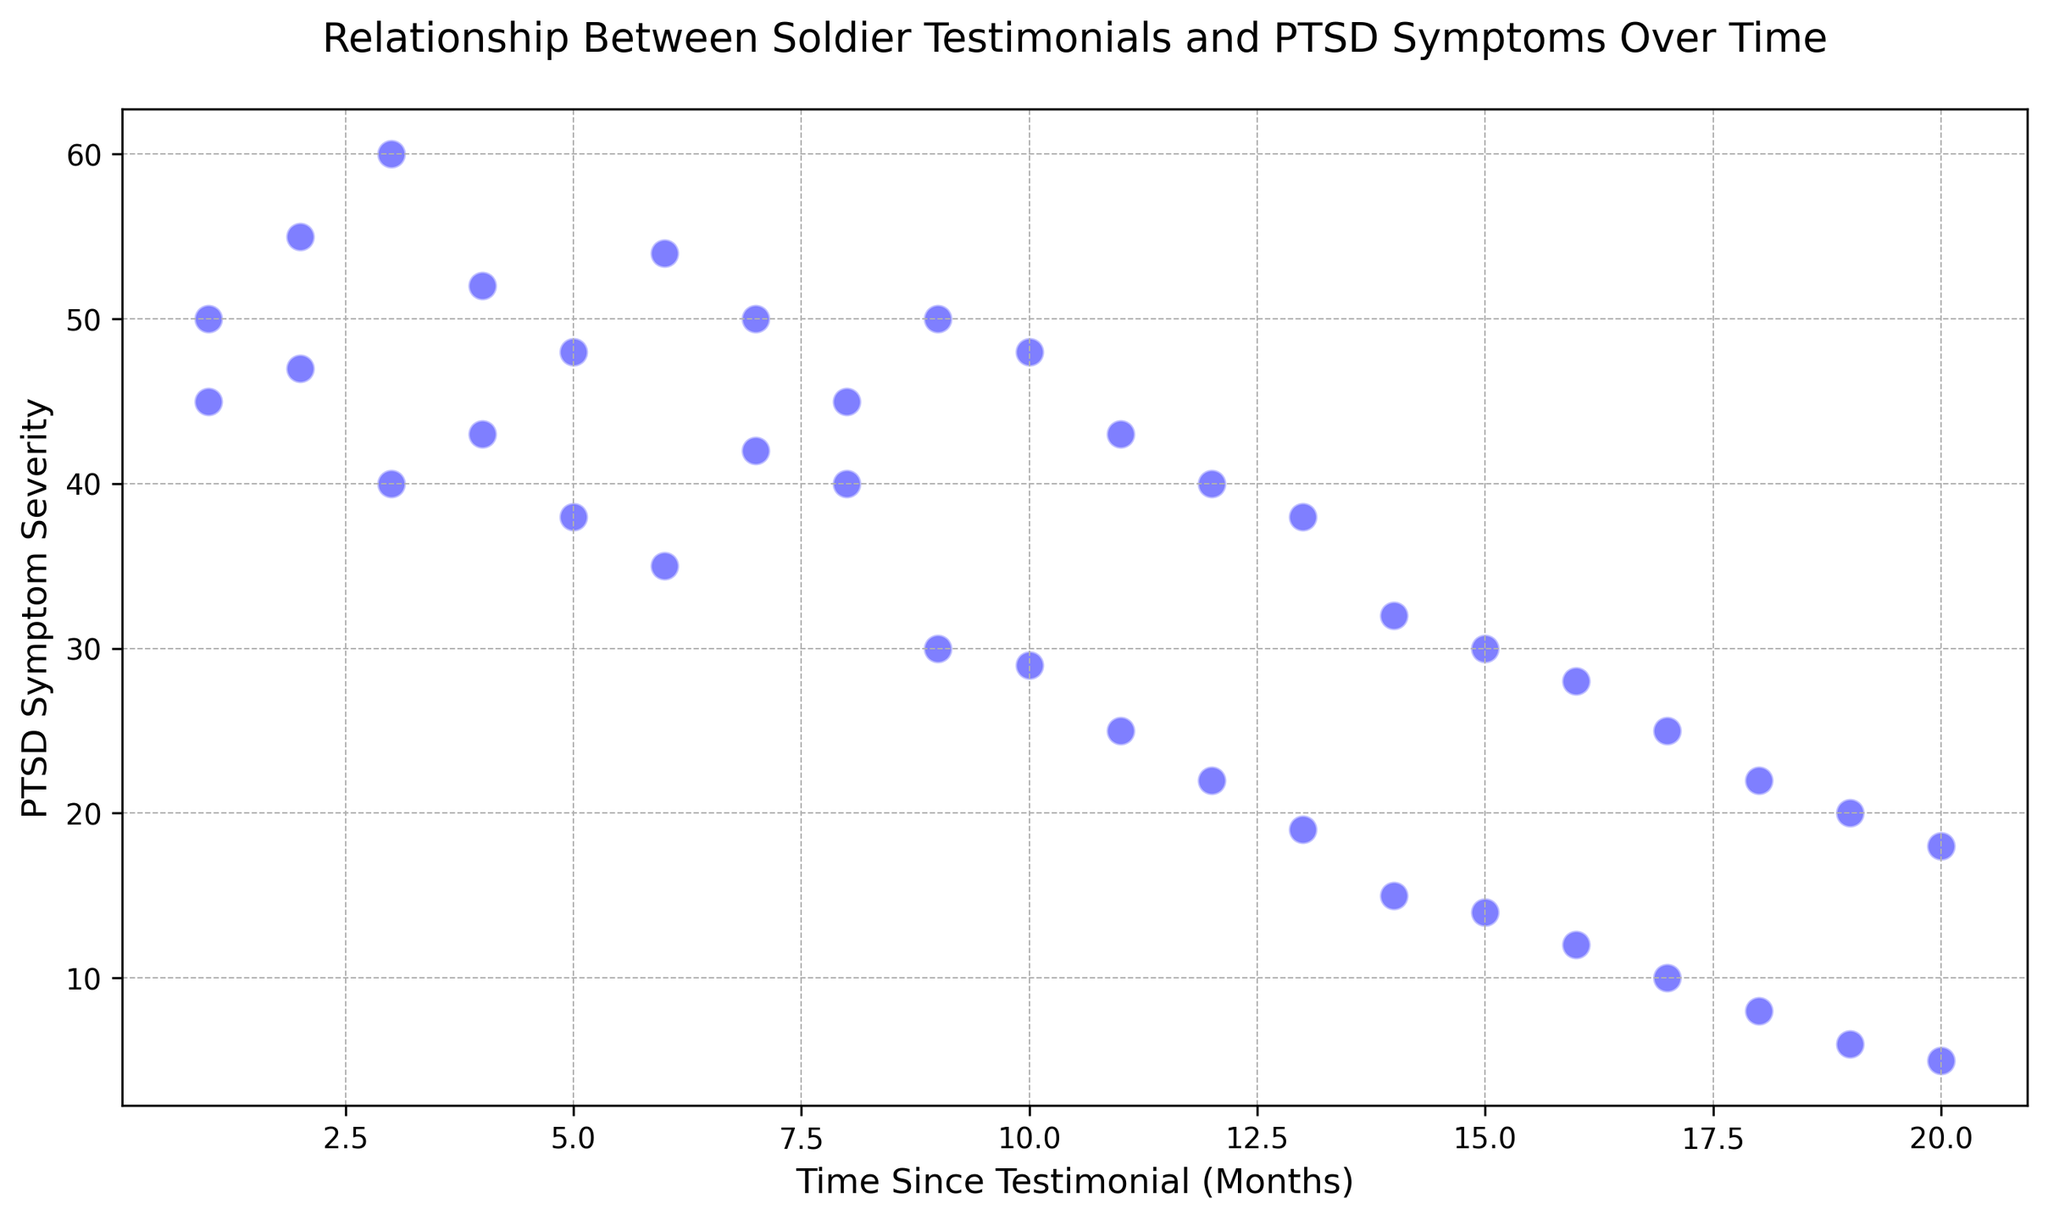What is the trend of PTSD symptom severity over time? To identify the trend, observe how the PTSD symptom severity values change as the time since testimonial increases along the x-axis. In general, the points tend to decrease as time progresses, indicating that PTSD symptoms become less severe over time.
Answer: Decreasing trend Which month shows the highest PTSD symptom severity? Look at the y-axis to find the highest point. The highest PTSD symptom severity is 60, which occurs at month 3.
Answer: Month 3 Is there any month where PTSD symptom severity is below 10? Examine the y-axis and look for points below the 10 mark. The lowest PTSD symptom severity values are 8, 6, and 5, which occur at months 18, 19, and 20 respectively.
Answer: Yes, months 18, 19, and 20 How do the PTSD symptom severities at months 6 and 7 compare with each other? At month 6, the values are 35 and 54. At month 7, the values are 42 and 50. Comparing these, month 6 has one value higher and one lower than month 7.
Answer: Mixed comparison, one higher and one lower What is the combined PTSD symptom severity of testimonials given at month 10? Sum the PTSD symptom severity values at month 10. These are 29 and 48. So, the combined severity is 29 + 48 = 77.
Answer: 77 What is the average PTSD symptom severity at months where it is exactly recorded? Identify months with recorded PTSD symptom severities, then calculate the average. For example, for months 1-3, the recorded severities are 45, 50, 47, 55, 40, and 60. The average is (45 + 50 + 47 + 55 + 40 + 60) / 6 = 49.5.
Answer: 49.5 (for months 1-3) How many data points have a PTSD symptom severity above 50? Count the points on the graph where the severity exceeds 50. Such points are 7 in number, occurring at months 1, 2, 3, 6, 6, 3, 9 and 10.
Answer: 7 At which months do we see the first drop below 20 in PTSD symptom severity? Observe the first point where the y-axis value drops below 20. This happens at month 13 with a value of 19.
Answer: Month 13 Compare PTSD symptom severities between months 4 and 5. Which month has the higher overall number? Month 4 has severities of 43 and 52. Month 5 has severities of 38 and 48. Summing these groups, month 4 has 43 + 52 = 95 and month 5 has 38 + 48 = 86. Therefore, month 4 has the higher total severity.
Answer: Month 4 What is the range of PTSD symptom severity between months 10 and 15? Identify the highest and lowest PTSD symptom severities between months 10 and 15. The highest is 48 and the lowest is 14. The range is 48 - 14 = 34.
Answer: 34 